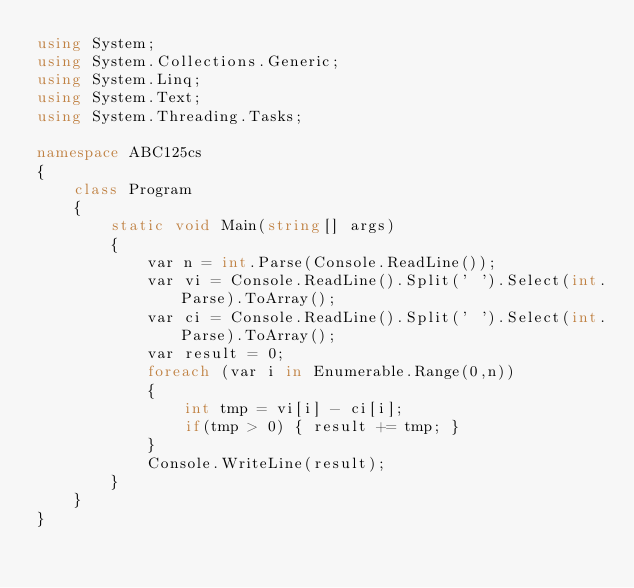Convert code to text. <code><loc_0><loc_0><loc_500><loc_500><_C#_>using System;
using System.Collections.Generic;
using System.Linq;
using System.Text;
using System.Threading.Tasks;

namespace ABC125cs
{
    class Program
    {
        static void Main(string[] args)
        {
            var n = int.Parse(Console.ReadLine());
            var vi = Console.ReadLine().Split(' ').Select(int.Parse).ToArray();
            var ci = Console.ReadLine().Split(' ').Select(int.Parse).ToArray();
            var result = 0;
            foreach (var i in Enumerable.Range(0,n))
            {
                int tmp = vi[i] - ci[i];
                if(tmp > 0) { result += tmp; }
            }
            Console.WriteLine(result);
        }
    }
}
</code> 